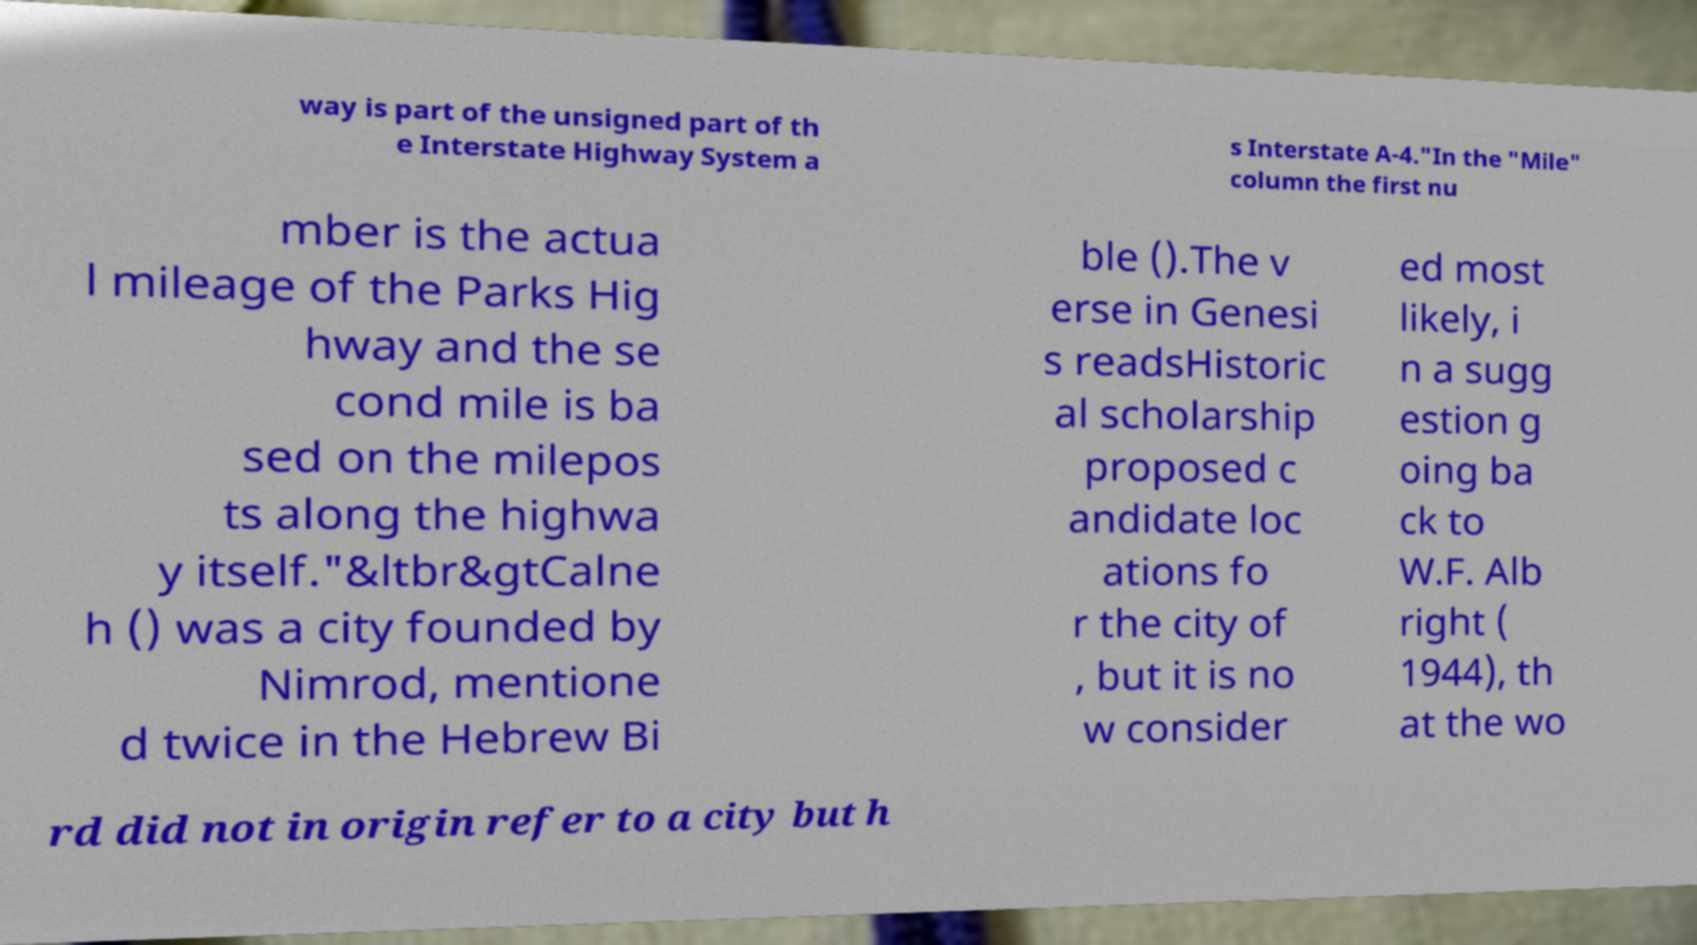Could you assist in decoding the text presented in this image and type it out clearly? way is part of the unsigned part of th e Interstate Highway System a s Interstate A-4."In the "Mile" column the first nu mber is the actua l mileage of the Parks Hig hway and the se cond mile is ba sed on the milepos ts along the highwa y itself."&ltbr&gtCalne h () was a city founded by Nimrod, mentione d twice in the Hebrew Bi ble ().The v erse in Genesi s readsHistoric al scholarship proposed c andidate loc ations fo r the city of , but it is no w consider ed most likely, i n a sugg estion g oing ba ck to W.F. Alb right ( 1944), th at the wo rd did not in origin refer to a city but h 